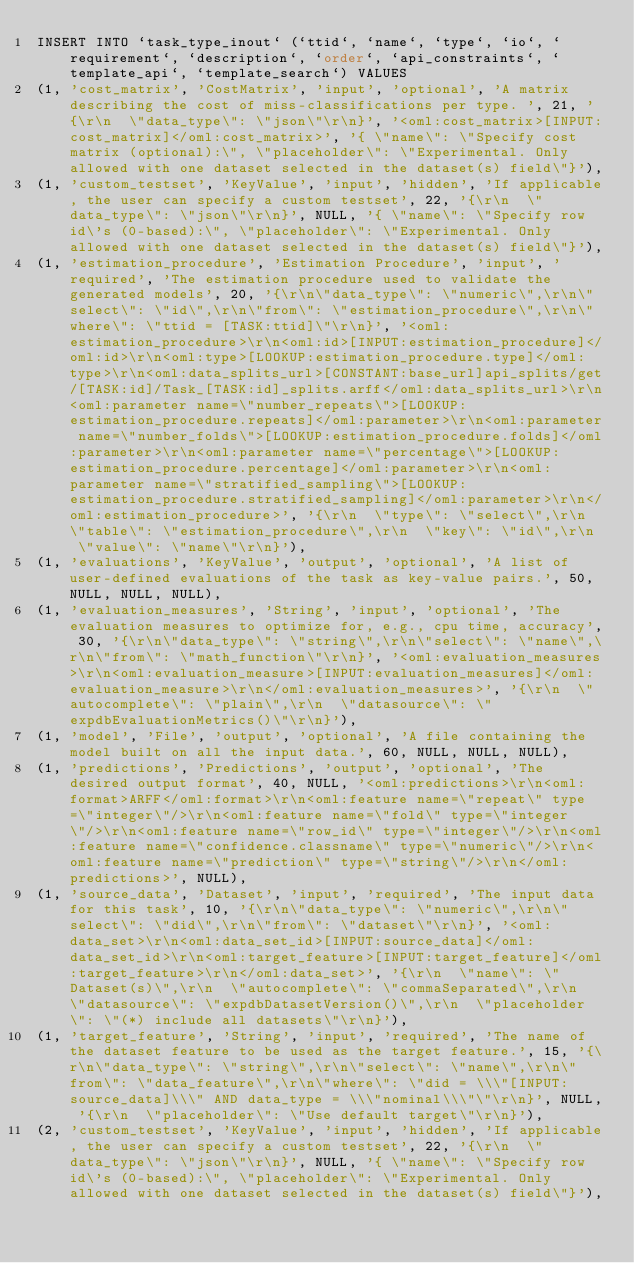Convert code to text. <code><loc_0><loc_0><loc_500><loc_500><_SQL_>INSERT INTO `task_type_inout` (`ttid`, `name`, `type`, `io`, `requirement`, `description`, `order`, `api_constraints`, `template_api`, `template_search`) VALUES
(1, 'cost_matrix', 'CostMatrix', 'input', 'optional', 'A matrix describing the cost of miss-classifications per type. ', 21, '{\r\n  \"data_type\": \"json\"\r\n}', '<oml:cost_matrix>[INPUT:cost_matrix]</oml:cost_matrix>', '{ \"name\": \"Specify cost matrix (optional):\", \"placeholder\": \"Experimental. Only allowed with one dataset selected in the dataset(s) field\"}'),
(1, 'custom_testset', 'KeyValue', 'input', 'hidden', 'If applicable, the user can specify a custom testset', 22, '{\r\n  \"data_type\": \"json\"\r\n}', NULL, '{ \"name\": \"Specify row id\'s (0-based):\", \"placeholder\": \"Experimental. Only allowed with one dataset selected in the dataset(s) field\"}'),
(1, 'estimation_procedure', 'Estimation Procedure', 'input', 'required', 'The estimation procedure used to validate the generated models', 20, '{\r\n\"data_type\": \"numeric\",\r\n\"select\": \"id\",\r\n\"from\": \"estimation_procedure\",\r\n\"where\": \"ttid = [TASK:ttid]\"\r\n}', '<oml:estimation_procedure>\r\n<oml:id>[INPUT:estimation_procedure]</oml:id>\r\n<oml:type>[LOOKUP:estimation_procedure.type]</oml:type>\r\n<oml:data_splits_url>[CONSTANT:base_url]api_splits/get/[TASK:id]/Task_[TASK:id]_splits.arff</oml:data_splits_url>\r\n<oml:parameter name=\"number_repeats\">[LOOKUP:estimation_procedure.repeats]</oml:parameter>\r\n<oml:parameter name=\"number_folds\">[LOOKUP:estimation_procedure.folds]</oml:parameter>\r\n<oml:parameter name=\"percentage\">[LOOKUP:estimation_procedure.percentage]</oml:parameter>\r\n<oml:parameter name=\"stratified_sampling\">[LOOKUP:estimation_procedure.stratified_sampling]</oml:parameter>\r\n</oml:estimation_procedure>', '{\r\n  \"type\": \"select\",\r\n  \"table\": \"estimation_procedure\",\r\n  \"key\": \"id\",\r\n  \"value\": \"name\"\r\n}'),
(1, 'evaluations', 'KeyValue', 'output', 'optional', 'A list of user-defined evaluations of the task as key-value pairs.', 50, NULL, NULL, NULL),
(1, 'evaluation_measures', 'String', 'input', 'optional', 'The evaluation measures to optimize for, e.g., cpu time, accuracy', 30, '{\r\n\"data_type\": \"string\",\r\n\"select\": \"name\",\r\n\"from\": \"math_function\"\r\n}', '<oml:evaluation_measures>\r\n<oml:evaluation_measure>[INPUT:evaluation_measures]</oml:evaluation_measure>\r\n</oml:evaluation_measures>', '{\r\n  \"autocomplete\": \"plain\",\r\n  \"datasource\": \"expdbEvaluationMetrics()\"\r\n}'),
(1, 'model', 'File', 'output', 'optional', 'A file containing the model built on all the input data.', 60, NULL, NULL, NULL),
(1, 'predictions', 'Predictions', 'output', 'optional', 'The desired output format', 40, NULL, '<oml:predictions>\r\n<oml:format>ARFF</oml:format>\r\n<oml:feature name=\"repeat\" type=\"integer\"/>\r\n<oml:feature name=\"fold\" type=\"integer\"/>\r\n<oml:feature name=\"row_id\" type=\"integer\"/>\r\n<oml:feature name=\"confidence.classname\" type=\"numeric\"/>\r\n<oml:feature name=\"prediction\" type=\"string\"/>\r\n</oml:predictions>', NULL),
(1, 'source_data', 'Dataset', 'input', 'required', 'The input data for this task', 10, '{\r\n\"data_type\": \"numeric\",\r\n\"select\": \"did\",\r\n\"from\": \"dataset\"\r\n}', '<oml:data_set>\r\n<oml:data_set_id>[INPUT:source_data]</oml:data_set_id>\r\n<oml:target_feature>[INPUT:target_feature]</oml:target_feature>\r\n</oml:data_set>', '{\r\n  \"name\": \"Dataset(s)\",\r\n  \"autocomplete\": \"commaSeparated\",\r\n  \"datasource\": \"expdbDatasetVersion()\",\r\n  \"placeholder\": \"(*) include all datasets\"\r\n}'),
(1, 'target_feature', 'String', 'input', 'required', 'The name of the dataset feature to be used as the target feature.', 15, '{\r\n\"data_type\": \"string\",\r\n\"select\": \"name\",\r\n\"from\": \"data_feature\",\r\n\"where\": \"did = \\\"[INPUT:source_data]\\\" AND data_type = \\\"nominal\\\"\"\r\n}', NULL, '{\r\n  \"placeholder\": \"Use default target\"\r\n}'),
(2, 'custom_testset', 'KeyValue', 'input', 'hidden', 'If applicable, the user can specify a custom testset', 22, '{\r\n  \"data_type\": \"json\"\r\n}', NULL, '{ \"name\": \"Specify row id\'s (0-based):\", \"placeholder\": \"Experimental. Only allowed with one dataset selected in the dataset(s) field\"}'),</code> 